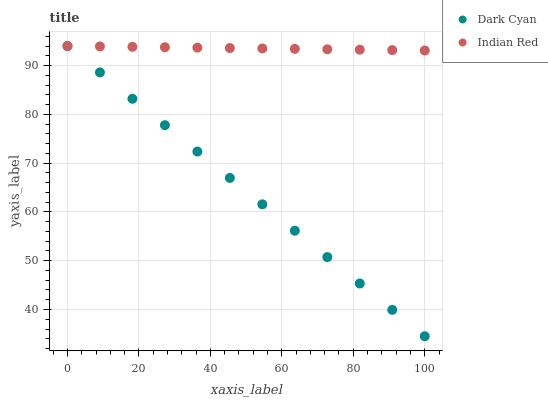Does Dark Cyan have the minimum area under the curve?
Answer yes or no. Yes. Does Indian Red have the maximum area under the curve?
Answer yes or no. Yes. Does Indian Red have the minimum area under the curve?
Answer yes or no. No. Is Dark Cyan the smoothest?
Answer yes or no. Yes. Is Indian Red the roughest?
Answer yes or no. Yes. Is Indian Red the smoothest?
Answer yes or no. No. Does Dark Cyan have the lowest value?
Answer yes or no. Yes. Does Indian Red have the lowest value?
Answer yes or no. No. Does Indian Red have the highest value?
Answer yes or no. Yes. Does Dark Cyan intersect Indian Red?
Answer yes or no. Yes. Is Dark Cyan less than Indian Red?
Answer yes or no. No. Is Dark Cyan greater than Indian Red?
Answer yes or no. No. 